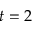Convert formula to latex. <formula><loc_0><loc_0><loc_500><loc_500>t = 2</formula> 